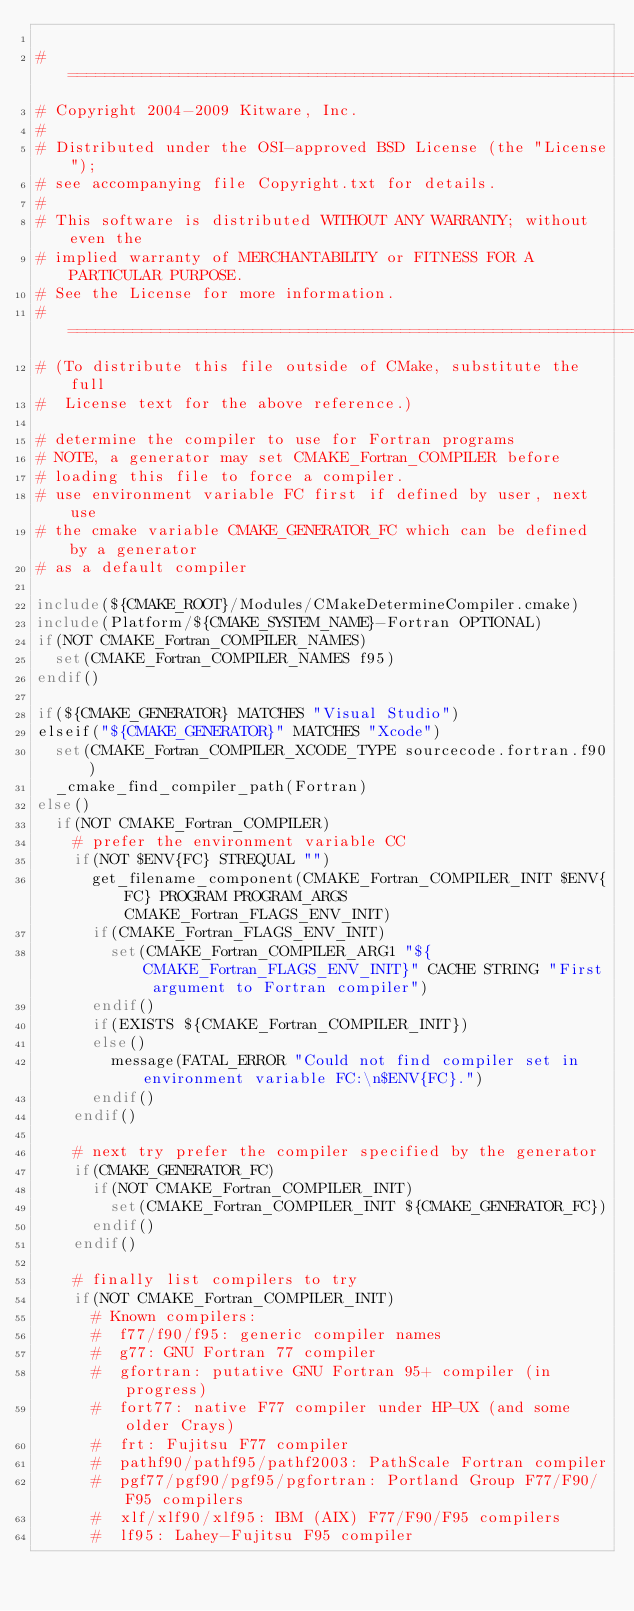Convert code to text. <code><loc_0><loc_0><loc_500><loc_500><_CMake_>
#=============================================================================
# Copyright 2004-2009 Kitware, Inc.
#
# Distributed under the OSI-approved BSD License (the "License");
# see accompanying file Copyright.txt for details.
#
# This software is distributed WITHOUT ANY WARRANTY; without even the
# implied warranty of MERCHANTABILITY or FITNESS FOR A PARTICULAR PURPOSE.
# See the License for more information.
#=============================================================================
# (To distribute this file outside of CMake, substitute the full
#  License text for the above reference.)

# determine the compiler to use for Fortran programs
# NOTE, a generator may set CMAKE_Fortran_COMPILER before
# loading this file to force a compiler.
# use environment variable FC first if defined by user, next use
# the cmake variable CMAKE_GENERATOR_FC which can be defined by a generator
# as a default compiler

include(${CMAKE_ROOT}/Modules/CMakeDetermineCompiler.cmake)
include(Platform/${CMAKE_SYSTEM_NAME}-Fortran OPTIONAL)
if(NOT CMAKE_Fortran_COMPILER_NAMES)
  set(CMAKE_Fortran_COMPILER_NAMES f95)
endif()

if(${CMAKE_GENERATOR} MATCHES "Visual Studio")
elseif("${CMAKE_GENERATOR}" MATCHES "Xcode")
  set(CMAKE_Fortran_COMPILER_XCODE_TYPE sourcecode.fortran.f90)
  _cmake_find_compiler_path(Fortran)
else()
  if(NOT CMAKE_Fortran_COMPILER)
    # prefer the environment variable CC
    if(NOT $ENV{FC} STREQUAL "")
      get_filename_component(CMAKE_Fortran_COMPILER_INIT $ENV{FC} PROGRAM PROGRAM_ARGS CMAKE_Fortran_FLAGS_ENV_INIT)
      if(CMAKE_Fortran_FLAGS_ENV_INIT)
        set(CMAKE_Fortran_COMPILER_ARG1 "${CMAKE_Fortran_FLAGS_ENV_INIT}" CACHE STRING "First argument to Fortran compiler")
      endif()
      if(EXISTS ${CMAKE_Fortran_COMPILER_INIT})
      else()
        message(FATAL_ERROR "Could not find compiler set in environment variable FC:\n$ENV{FC}.")
      endif()
    endif()

    # next try prefer the compiler specified by the generator
    if(CMAKE_GENERATOR_FC)
      if(NOT CMAKE_Fortran_COMPILER_INIT)
        set(CMAKE_Fortran_COMPILER_INIT ${CMAKE_GENERATOR_FC})
      endif()
    endif()

    # finally list compilers to try
    if(NOT CMAKE_Fortran_COMPILER_INIT)
      # Known compilers:
      #  f77/f90/f95: generic compiler names
      #  g77: GNU Fortran 77 compiler
      #  gfortran: putative GNU Fortran 95+ compiler (in progress)
      #  fort77: native F77 compiler under HP-UX (and some older Crays)
      #  frt: Fujitsu F77 compiler
      #  pathf90/pathf95/pathf2003: PathScale Fortran compiler
      #  pgf77/pgf90/pgf95/pgfortran: Portland Group F77/F90/F95 compilers
      #  xlf/xlf90/xlf95: IBM (AIX) F77/F90/F95 compilers
      #  lf95: Lahey-Fujitsu F95 compiler</code> 